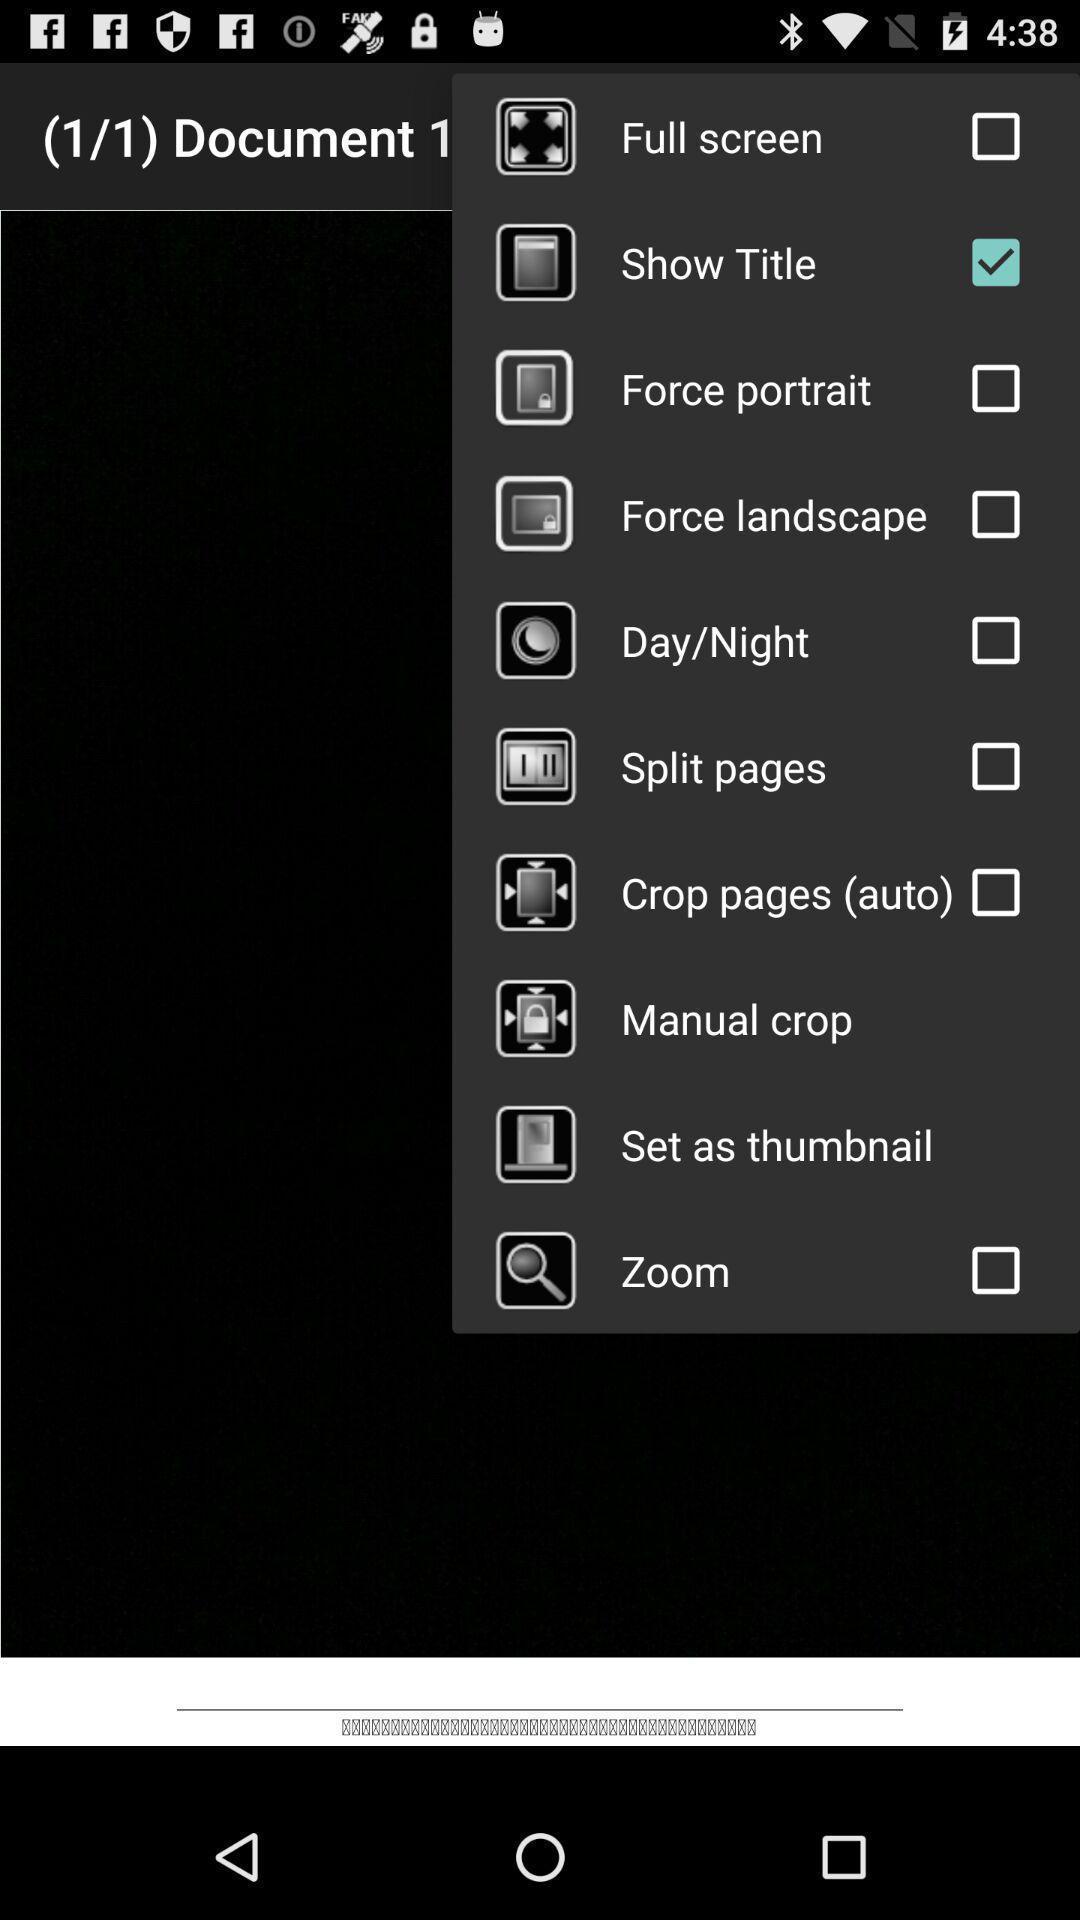Provide a description of this screenshot. Pop up displaying the multiple list of options. 